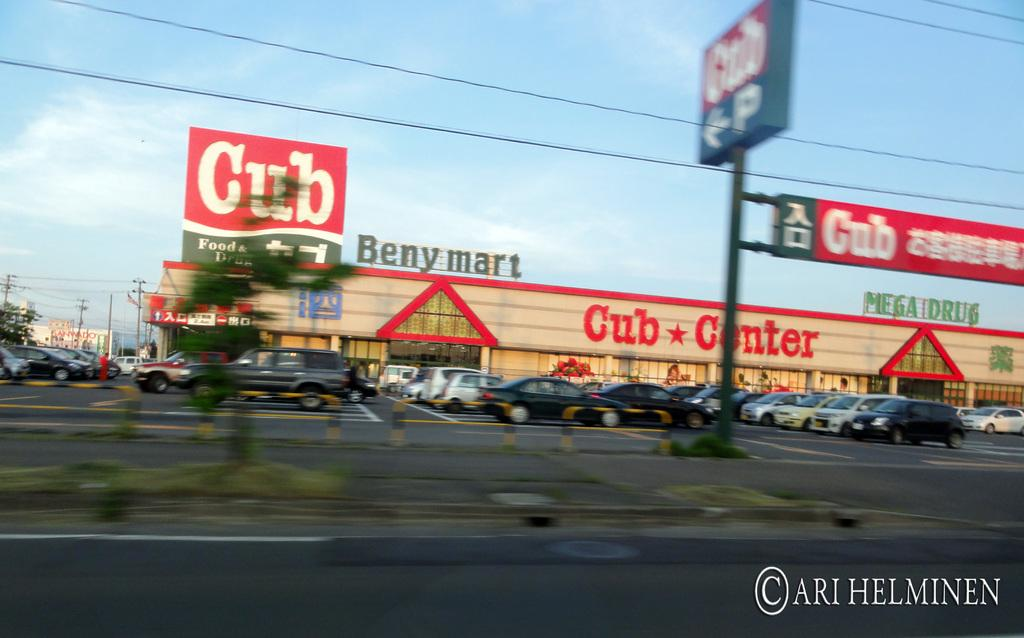<image>
Share a concise interpretation of the image provided. club center shopping center with lots of cars in pakring lot 